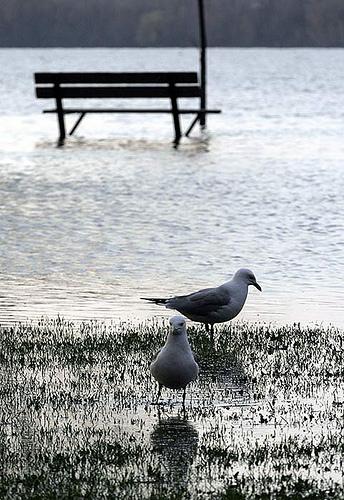Is it flooded?
Concise answer only. Yes. Are there any baby birds on the ground?
Quick response, please. No. What is in the middle of the water?
Quick response, please. Bench. Do you see 3 pelicans?
Quick response, please. No. 